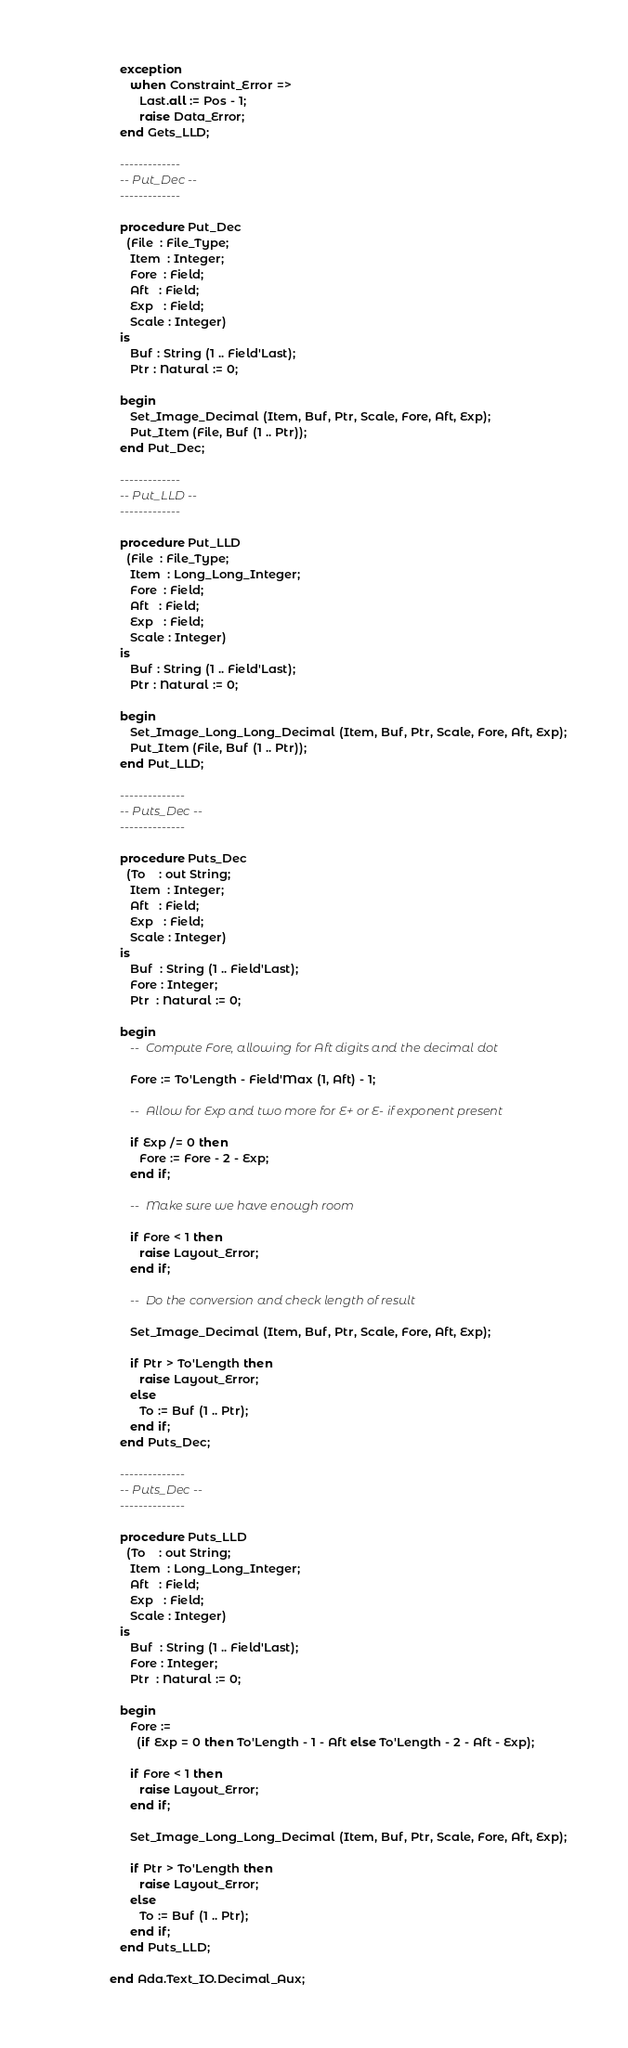Convert code to text. <code><loc_0><loc_0><loc_500><loc_500><_Ada_>   exception
      when Constraint_Error =>
         Last.all := Pos - 1;
         raise Data_Error;
   end Gets_LLD;

   -------------
   -- Put_Dec --
   -------------

   procedure Put_Dec
     (File  : File_Type;
      Item  : Integer;
      Fore  : Field;
      Aft   : Field;
      Exp   : Field;
      Scale : Integer)
   is
      Buf : String (1 .. Field'Last);
      Ptr : Natural := 0;

   begin
      Set_Image_Decimal (Item, Buf, Ptr, Scale, Fore, Aft, Exp);
      Put_Item (File, Buf (1 .. Ptr));
   end Put_Dec;

   -------------
   -- Put_LLD --
   -------------

   procedure Put_LLD
     (File  : File_Type;
      Item  : Long_Long_Integer;
      Fore  : Field;
      Aft   : Field;
      Exp   : Field;
      Scale : Integer)
   is
      Buf : String (1 .. Field'Last);
      Ptr : Natural := 0;

   begin
      Set_Image_Long_Long_Decimal (Item, Buf, Ptr, Scale, Fore, Aft, Exp);
      Put_Item (File, Buf (1 .. Ptr));
   end Put_LLD;

   --------------
   -- Puts_Dec --
   --------------

   procedure Puts_Dec
     (To    : out String;
      Item  : Integer;
      Aft   : Field;
      Exp   : Field;
      Scale : Integer)
   is
      Buf  : String (1 .. Field'Last);
      Fore : Integer;
      Ptr  : Natural := 0;

   begin
      --  Compute Fore, allowing for Aft digits and the decimal dot

      Fore := To'Length - Field'Max (1, Aft) - 1;

      --  Allow for Exp and two more for E+ or E- if exponent present

      if Exp /= 0 then
         Fore := Fore - 2 - Exp;
      end if;

      --  Make sure we have enough room

      if Fore < 1 then
         raise Layout_Error;
      end if;

      --  Do the conversion and check length of result

      Set_Image_Decimal (Item, Buf, Ptr, Scale, Fore, Aft, Exp);

      if Ptr > To'Length then
         raise Layout_Error;
      else
         To := Buf (1 .. Ptr);
      end if;
   end Puts_Dec;

   --------------
   -- Puts_Dec --
   --------------

   procedure Puts_LLD
     (To    : out String;
      Item  : Long_Long_Integer;
      Aft   : Field;
      Exp   : Field;
      Scale : Integer)
   is
      Buf  : String (1 .. Field'Last);
      Fore : Integer;
      Ptr  : Natural := 0;

   begin
      Fore :=
        (if Exp = 0 then To'Length - 1 - Aft else To'Length - 2 - Aft - Exp);

      if Fore < 1 then
         raise Layout_Error;
      end if;

      Set_Image_Long_Long_Decimal (Item, Buf, Ptr, Scale, Fore, Aft, Exp);

      if Ptr > To'Length then
         raise Layout_Error;
      else
         To := Buf (1 .. Ptr);
      end if;
   end Puts_LLD;

end Ada.Text_IO.Decimal_Aux;
</code> 